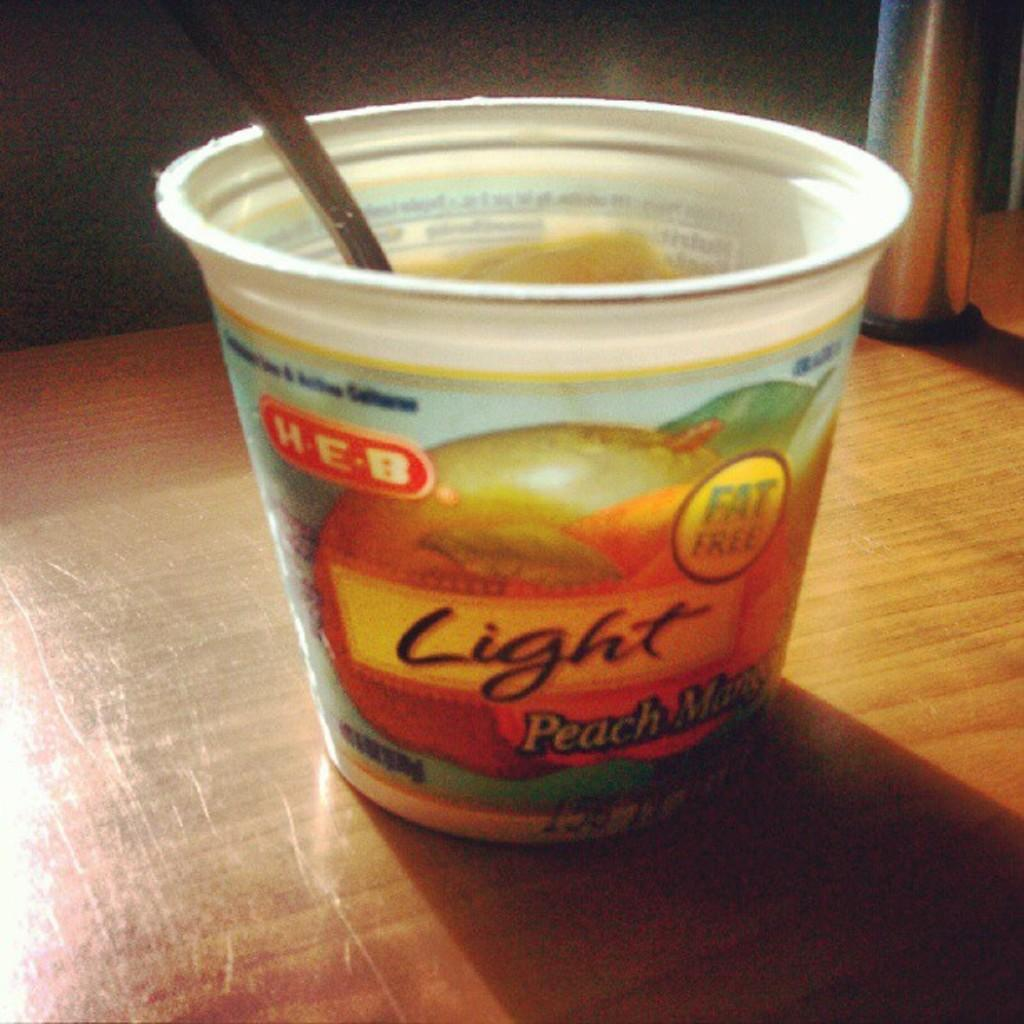What type of container is visible in the image? There is a plastic cup in the image. What is inside the plastic cup? There is a spoon inside the plastic cup. How many apples are being held by the boys in the image? There are no apples or boys present in the image. What is the condition of the ear of the person in the image? There is no person or ear visible in the image. 